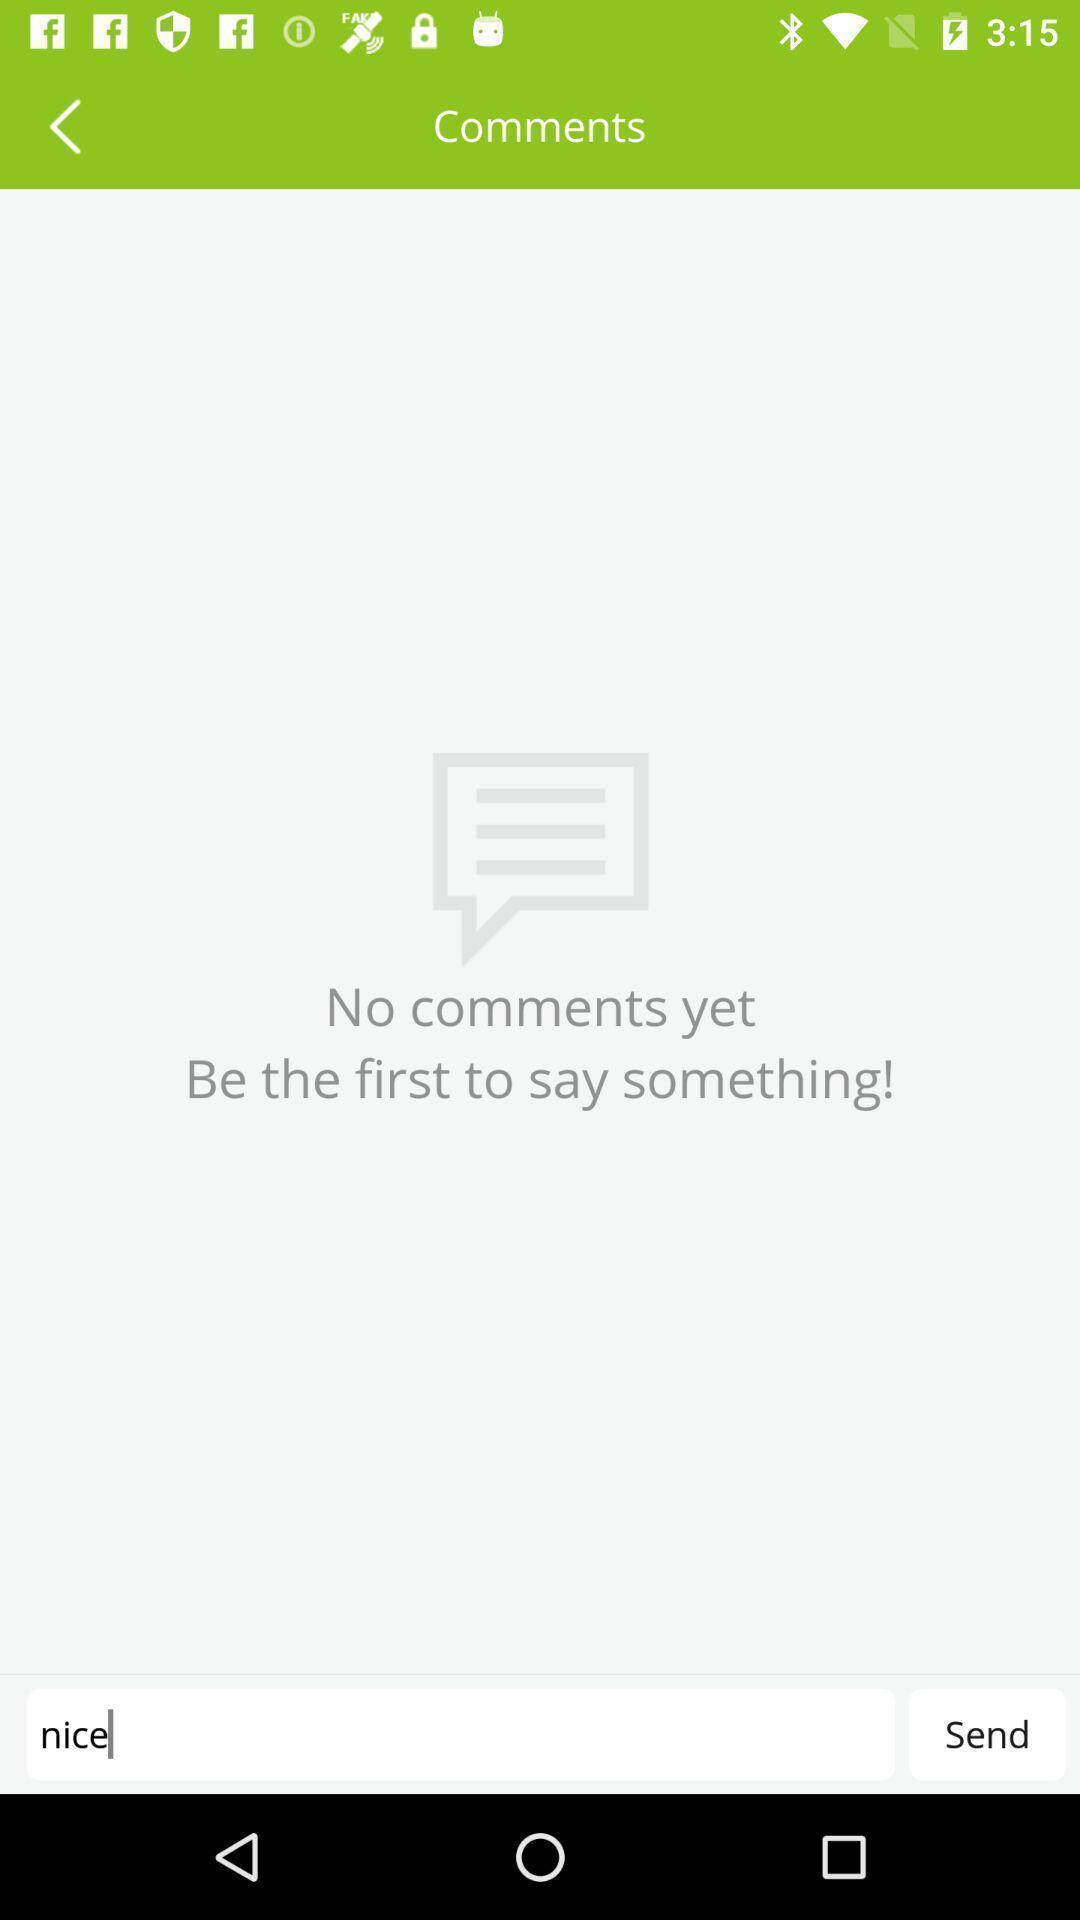Provide a textual representation of this image. Page displaying comment section in an audio streaming app. 